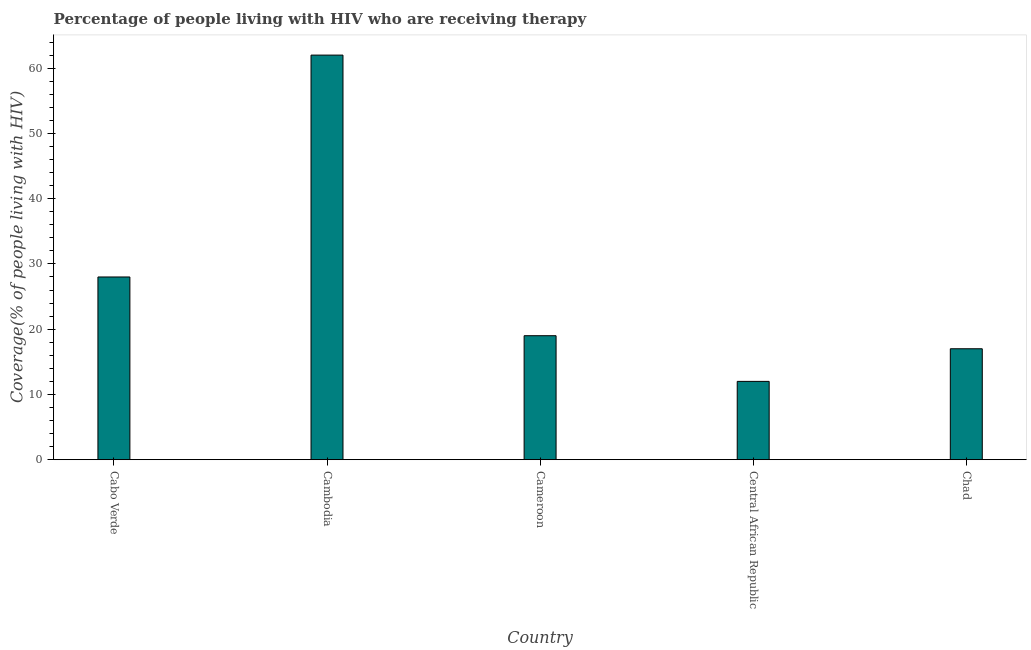Does the graph contain any zero values?
Your response must be concise. No. What is the title of the graph?
Provide a short and direct response. Percentage of people living with HIV who are receiving therapy. What is the label or title of the X-axis?
Your response must be concise. Country. What is the label or title of the Y-axis?
Make the answer very short. Coverage(% of people living with HIV). What is the antiretroviral therapy coverage in Cameroon?
Provide a succinct answer. 19. Across all countries, what is the maximum antiretroviral therapy coverage?
Offer a terse response. 62. In which country was the antiretroviral therapy coverage maximum?
Give a very brief answer. Cambodia. In which country was the antiretroviral therapy coverage minimum?
Offer a terse response. Central African Republic. What is the sum of the antiretroviral therapy coverage?
Give a very brief answer. 138. What is the average antiretroviral therapy coverage per country?
Ensure brevity in your answer.  27.6. What is the median antiretroviral therapy coverage?
Provide a short and direct response. 19. What is the ratio of the antiretroviral therapy coverage in Central African Republic to that in Chad?
Your answer should be compact. 0.71. Is the difference between the antiretroviral therapy coverage in Cabo Verde and Chad greater than the difference between any two countries?
Ensure brevity in your answer.  No. What is the difference between the highest and the second highest antiretroviral therapy coverage?
Offer a very short reply. 34. Is the sum of the antiretroviral therapy coverage in Central African Republic and Chad greater than the maximum antiretroviral therapy coverage across all countries?
Keep it short and to the point. No. What is the difference between the highest and the lowest antiretroviral therapy coverage?
Your answer should be compact. 50. Are all the bars in the graph horizontal?
Give a very brief answer. No. What is the difference between two consecutive major ticks on the Y-axis?
Provide a succinct answer. 10. Are the values on the major ticks of Y-axis written in scientific E-notation?
Provide a short and direct response. No. What is the difference between the Coverage(% of people living with HIV) in Cabo Verde and Cambodia?
Offer a terse response. -34. What is the difference between the Coverage(% of people living with HIV) in Cambodia and Central African Republic?
Your answer should be compact. 50. What is the difference between the Coverage(% of people living with HIV) in Cambodia and Chad?
Provide a short and direct response. 45. What is the ratio of the Coverage(% of people living with HIV) in Cabo Verde to that in Cambodia?
Provide a short and direct response. 0.45. What is the ratio of the Coverage(% of people living with HIV) in Cabo Verde to that in Cameroon?
Ensure brevity in your answer.  1.47. What is the ratio of the Coverage(% of people living with HIV) in Cabo Verde to that in Central African Republic?
Your answer should be compact. 2.33. What is the ratio of the Coverage(% of people living with HIV) in Cabo Verde to that in Chad?
Your response must be concise. 1.65. What is the ratio of the Coverage(% of people living with HIV) in Cambodia to that in Cameroon?
Give a very brief answer. 3.26. What is the ratio of the Coverage(% of people living with HIV) in Cambodia to that in Central African Republic?
Offer a very short reply. 5.17. What is the ratio of the Coverage(% of people living with HIV) in Cambodia to that in Chad?
Offer a very short reply. 3.65. What is the ratio of the Coverage(% of people living with HIV) in Cameroon to that in Central African Republic?
Provide a succinct answer. 1.58. What is the ratio of the Coverage(% of people living with HIV) in Cameroon to that in Chad?
Your response must be concise. 1.12. What is the ratio of the Coverage(% of people living with HIV) in Central African Republic to that in Chad?
Make the answer very short. 0.71. 